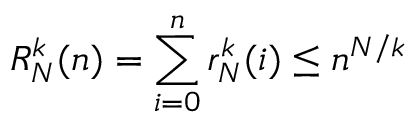<formula> <loc_0><loc_0><loc_500><loc_500>R _ { N } ^ { k } ( n ) = \sum _ { i = 0 } ^ { n } r _ { N } ^ { k } ( i ) \leq n ^ { N / k }</formula> 